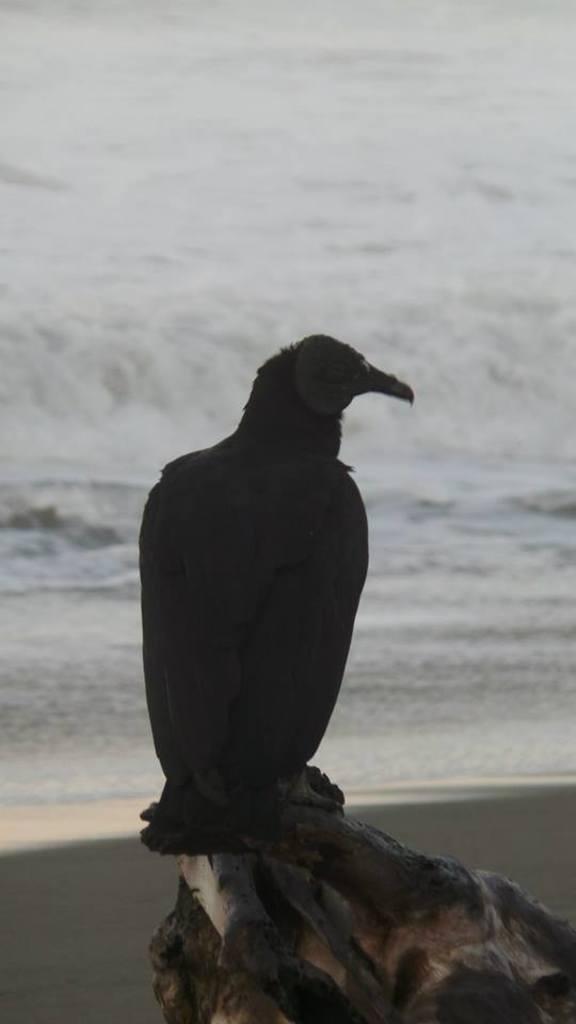What type of animal can be seen in the image? There is a bird in the image. Where is the bird located? The bird is on a trunk in the image. What can be seen in the background of the image? There is water visible in the background of the image. How does the bird help with the digestion of the passengers in the image? There are no passengers present in the image, and the bird is not involved in any digestion process. 